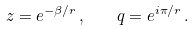<formula> <loc_0><loc_0><loc_500><loc_500>z = e ^ { - \beta / r } \, , \quad q = e ^ { i \pi / r } \, .</formula> 